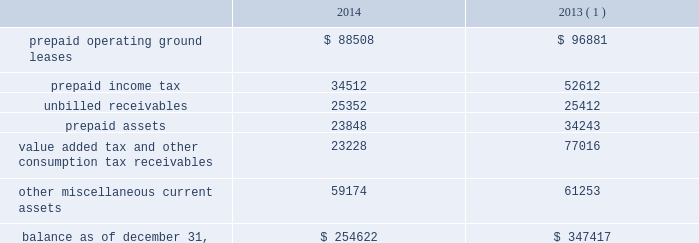American tower corporation and subsidiaries notes to consolidated financial statements of its outstanding restricted stock awards and stock options and uses the if-converted method to calculate the effect of its outstanding mandatory convertible preferred stock .
Retirement plan 2014the company has a 401 ( k ) plan covering substantially all employees who meet certain age and employment requirements .
For the years ended december 31 , 2014 and 2013 , the company matched 75% ( 75 % ) of the first 6% ( 6 % ) of a participant 2019s contributions .
The company 2019s matching contribution for the year ended december 31 , 2012 was 50% ( 50 % ) of the first 6% ( 6 % ) of a participant 2019s contributions .
For the years ended december 31 , 2014 , 2013 and 2012 , the company contributed approximately $ 6.5 million , $ 6.0 million and $ 4.4 million to the plan , respectively .
Accounting standards updates 2014in april 2014 , the financial accounting standards board ( the 201cfasb 201d ) issued additional guidance on reporting discontinued operations .
Under this guidance , only disposals representing a strategic shift in operations would be presented as discontinued operations .
This guidance requires expanded disclosure that provides information about the assets , liabilities , income and expenses of discontinued operations .
Additionally , the guidance requires additional disclosure for a disposal of a significant part of an entity that does not qualify for discontinued operations reporting .
This guidance is effective for reporting periods beginning on or after december 15 , 2014 , with early adoption permitted for disposals or classifications of assets as held-for-sale that have not been reported in financial statements previously issued or available for issuance .
The company chose to early adopt this guidance during the year ended december 31 , 2014 and the adoption did not have a material effect on the company 2019s financial statements .
In may 2014 , the fasb issued new revenue recognition guidance , which requires an entity to recognize revenue in an amount that reflects the consideration to which the entity expects to be entitled in exchange for the transfer of promised goods or services to customers .
The standard will replace most existing revenue recognition guidance in gaap and will become effective on january 1 , 2017 .
The standard permits the use of either the retrospective or cumulative effect transition method , and leases are not included in the scope of this standard .
The company is evaluating the impact this standard may have on its financial statements .
Prepaid and other current assets prepaid and other current assets consists of the following as of december 31 , ( in thousands ) : .
( 1 ) december 31 , 2013 balances have been revised to reflect purchase accounting measurement period adjustments. .
In millions , what were total tax related prepaids in 2014? 
Computations: (34512 + 23228)
Answer: 57740.0. 